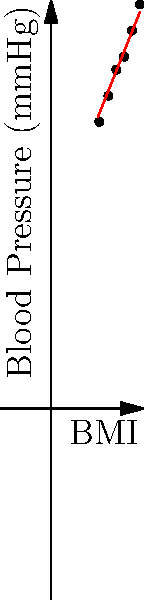The coordinate plane shows the relationship between BMI (Body Mass Index) and blood pressure for a sample population. Based on the trend observed, what would be the estimated blood pressure for an individual with a BMI of 30? To answer this question, we need to follow these steps:

1. Observe the trend: The graph shows a positive correlation between BMI and blood pressure. As BMI increases, blood pressure tends to increase as well.

2. Identify the trend line: The red line represents the general trend of the data points.

3. Locate the point of interest: We need to estimate the blood pressure for a BMI of 30.

4. Use the trend line to estimate: 
   - Find BMI 30 on the x-axis
   - Move vertically from this point until you intersect the trend line
   - From this intersection, move horizontally to the y-axis

5. Read the approximate value: The estimated blood pressure for a BMI of 30 is approximately 140 mmHg.

This estimation is based on the visual trend and may not be exact, but it provides a reasonable approximation given the data presented.
Answer: Approximately 140 mmHg 